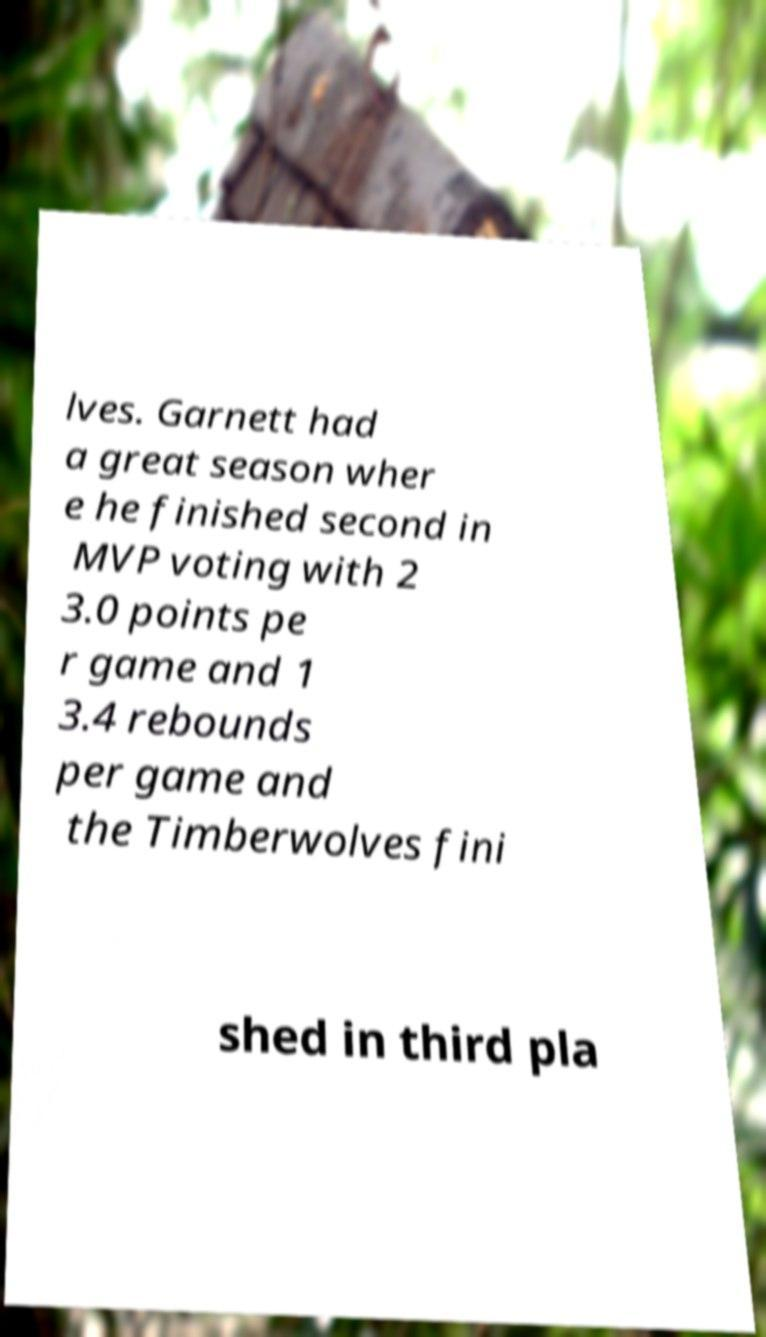I need the written content from this picture converted into text. Can you do that? lves. Garnett had a great season wher e he finished second in MVP voting with 2 3.0 points pe r game and 1 3.4 rebounds per game and the Timberwolves fini shed in third pla 